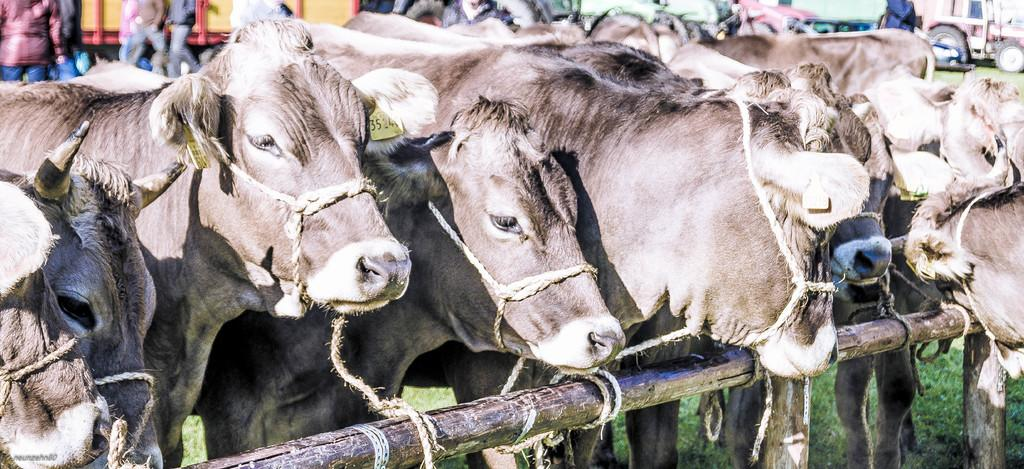What animals are present in the image? There are cows in the image. How are the cows restrained in the image? The cows are tied to a bamboo stick. What type of vegetation can be seen in the image? There is grass visible in the image. What type of haircut does the plant have in the image? There is no plant present in the image, and therefore no haircut can be observed. 